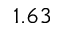Convert formula to latex. <formula><loc_0><loc_0><loc_500><loc_500>1 . 6 3</formula> 